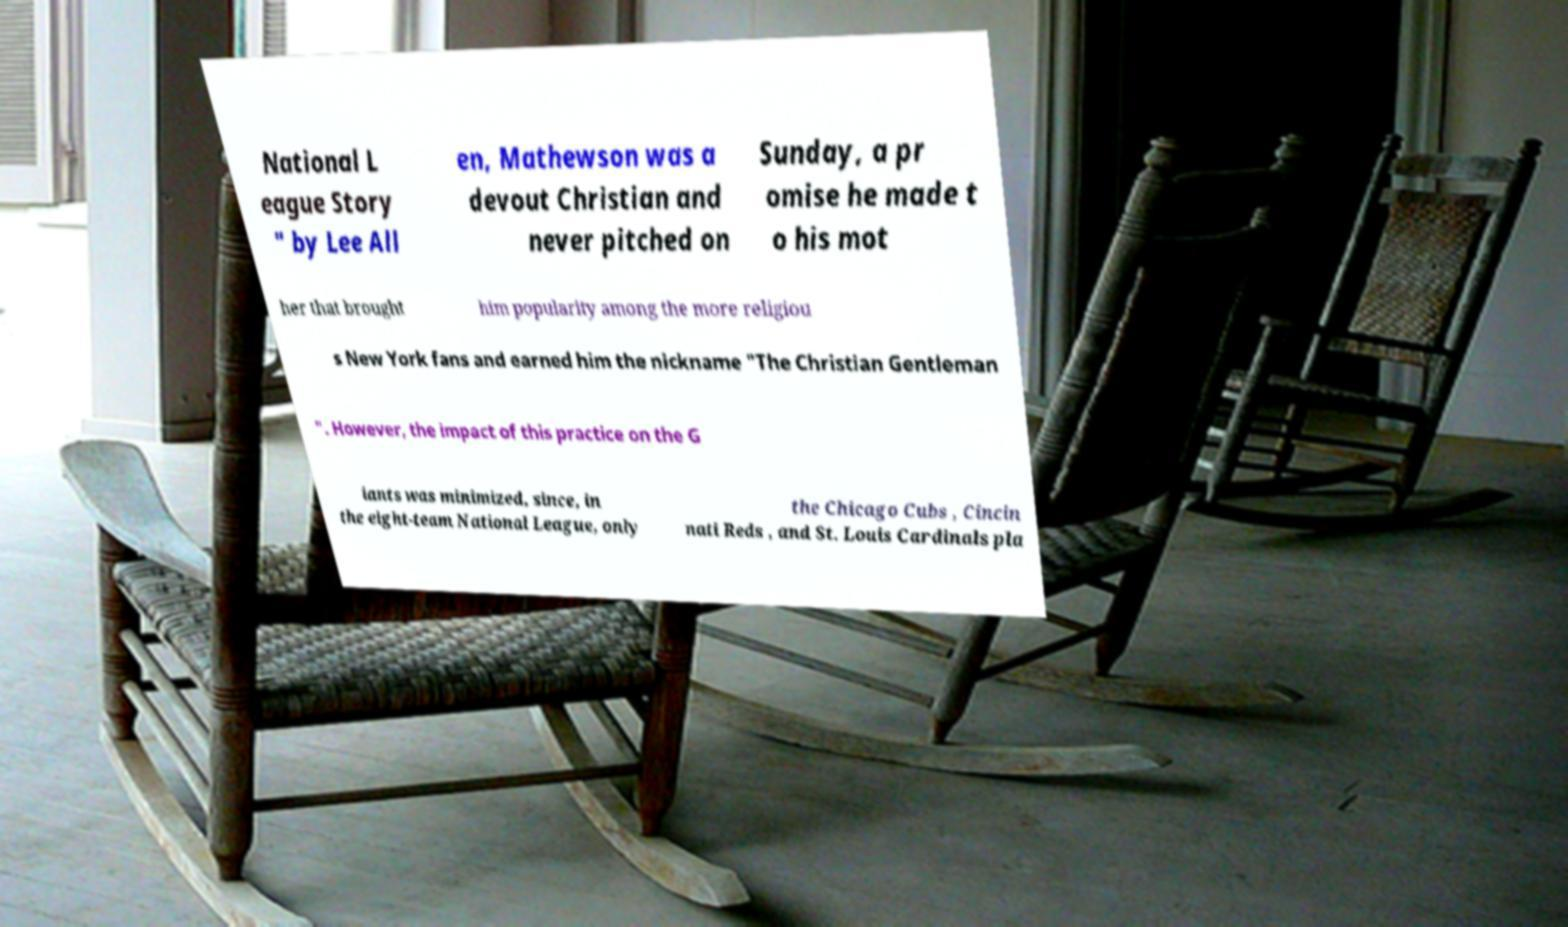There's text embedded in this image that I need extracted. Can you transcribe it verbatim? National L eague Story " by Lee All en, Mathewson was a devout Christian and never pitched on Sunday, a pr omise he made t o his mot her that brought him popularity among the more religiou s New York fans and earned him the nickname "The Christian Gentleman ". However, the impact of this practice on the G iants was minimized, since, in the eight-team National League, only the Chicago Cubs , Cincin nati Reds , and St. Louis Cardinals pla 